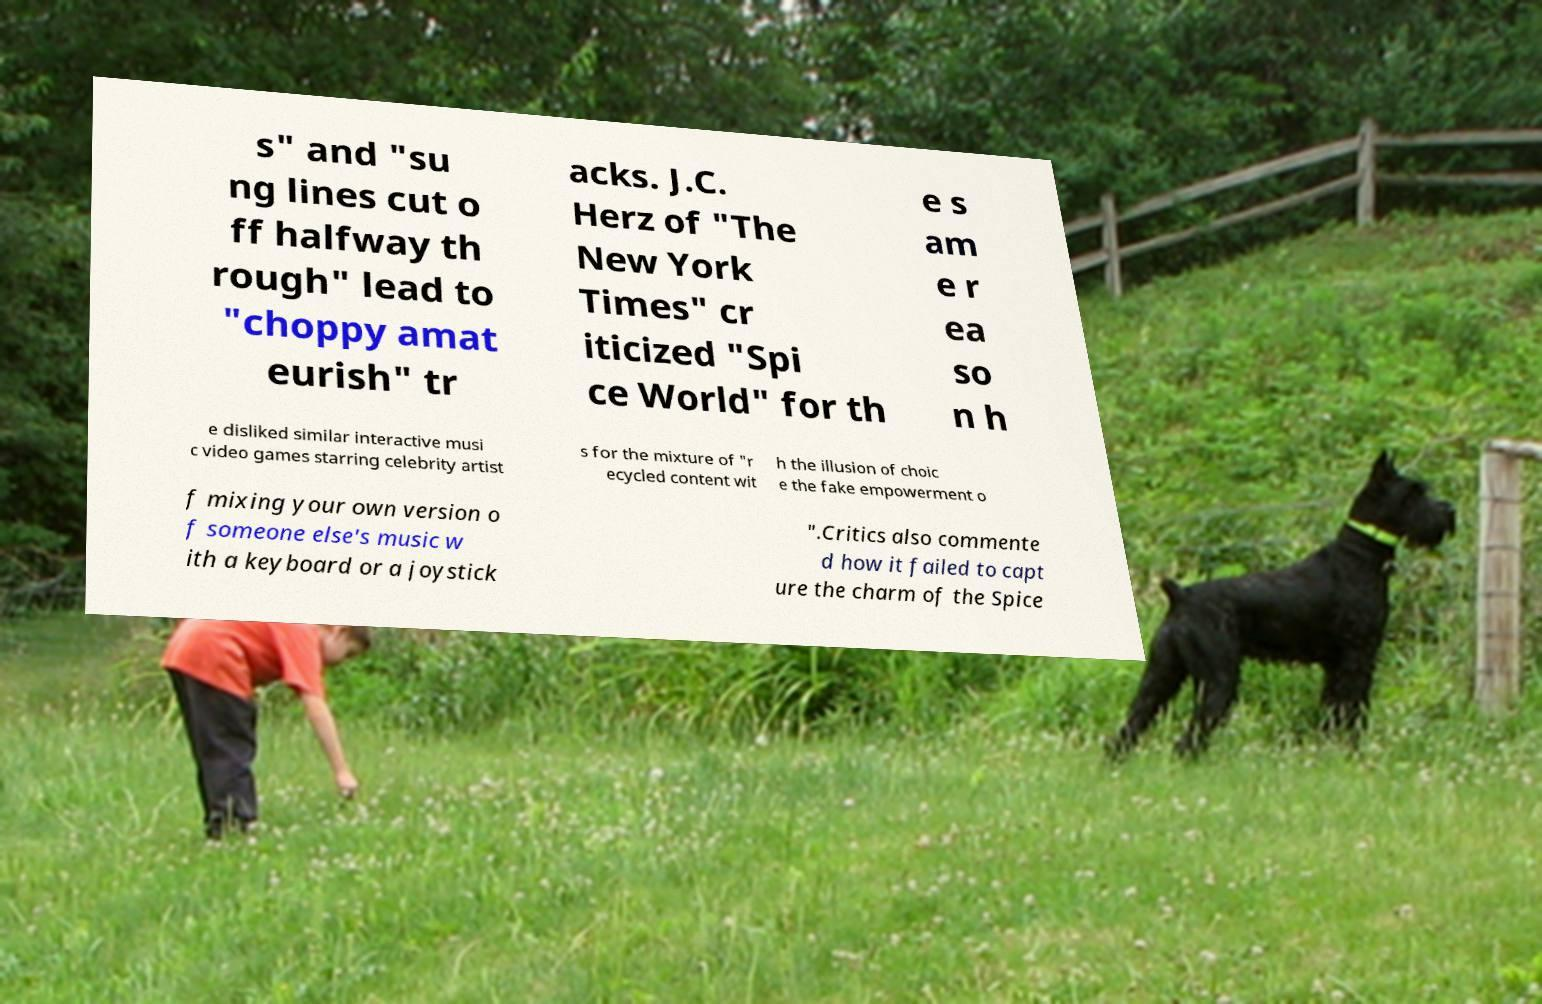There's text embedded in this image that I need extracted. Can you transcribe it verbatim? s" and "su ng lines cut o ff halfway th rough" lead to "choppy amat eurish" tr acks. J.C. Herz of "The New York Times" cr iticized "Spi ce World" for th e s am e r ea so n h e disliked similar interactive musi c video games starring celebrity artist s for the mixture of "r ecycled content wit h the illusion of choic e the fake empowerment o f mixing your own version o f someone else's music w ith a keyboard or a joystick ".Critics also commente d how it failed to capt ure the charm of the Spice 